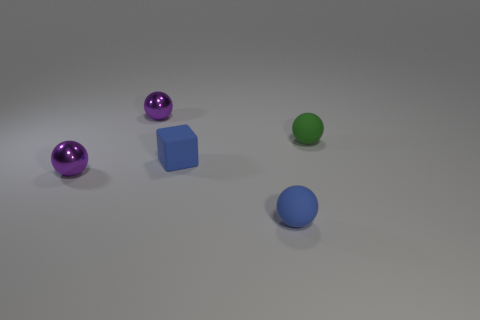There is a small thing that is the same color as the tiny matte block; what shape is it?
Offer a terse response. Sphere. There is a matte thing that is on the right side of the rubber object in front of the metal object in front of the small blue block; what is its shape?
Give a very brief answer. Sphere. The shiny ball behind the green thing is what color?
Make the answer very short. Purple. How many things are things that are in front of the small block or spheres on the right side of the tiny blue rubber block?
Offer a very short reply. 3. How many blue objects have the same shape as the green rubber object?
Provide a succinct answer. 1. There is a rubber cube that is the same size as the green matte thing; what color is it?
Provide a short and direct response. Blue. What is the color of the metal object that is on the right side of the purple object that is in front of the purple metal ball behind the green matte ball?
Offer a terse response. Purple. There is a block; is its size the same as the purple thing behind the small green sphere?
Offer a terse response. Yes. What number of objects are either blue rubber spheres or blue matte cubes?
Provide a succinct answer. 2. Is there a brown cube that has the same material as the blue block?
Make the answer very short. No. 